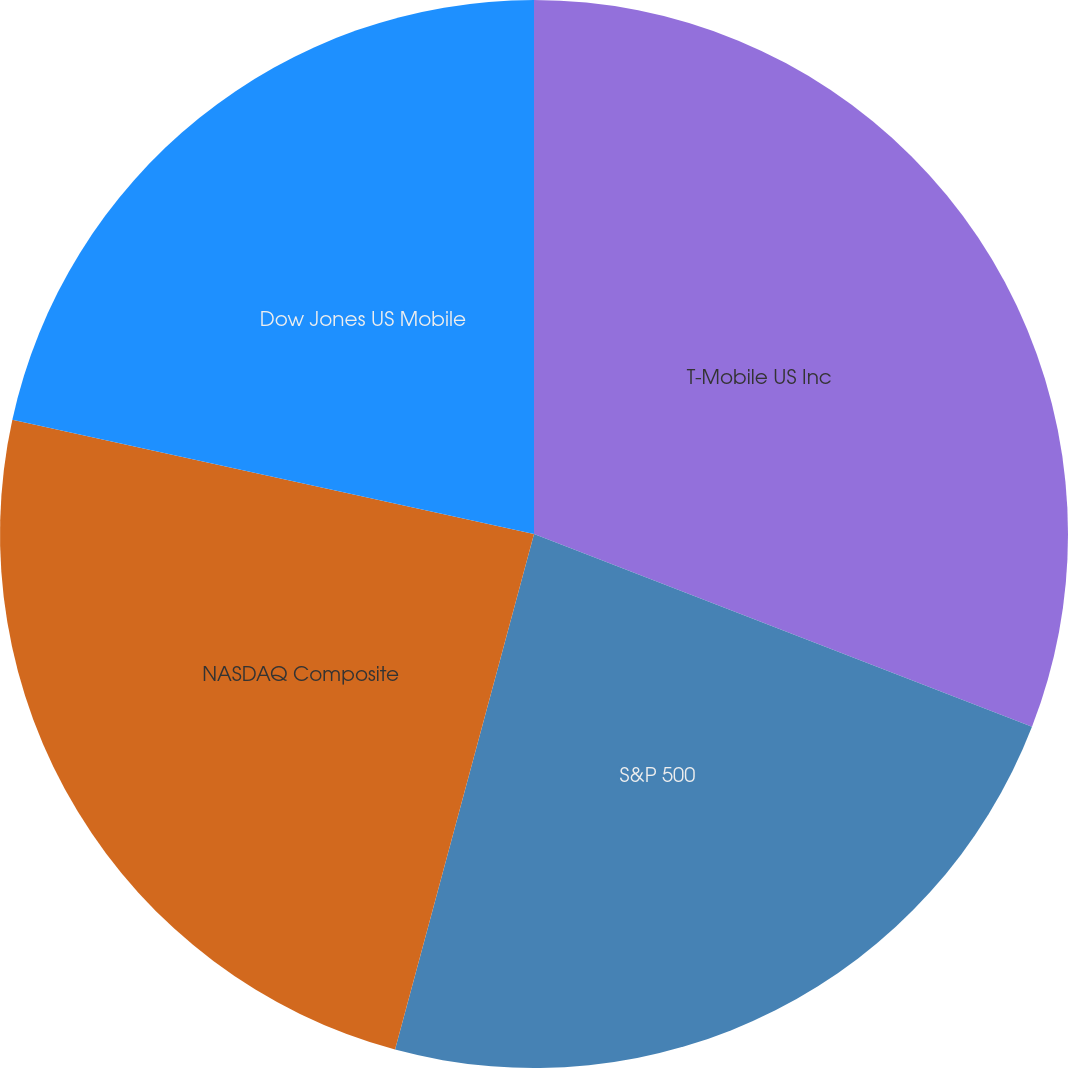Convert chart. <chart><loc_0><loc_0><loc_500><loc_500><pie_chart><fcel>T-Mobile US Inc<fcel>S&P 500<fcel>NASDAQ Composite<fcel>Dow Jones US Mobile<nl><fcel>30.88%<fcel>23.31%<fcel>24.24%<fcel>21.57%<nl></chart> 